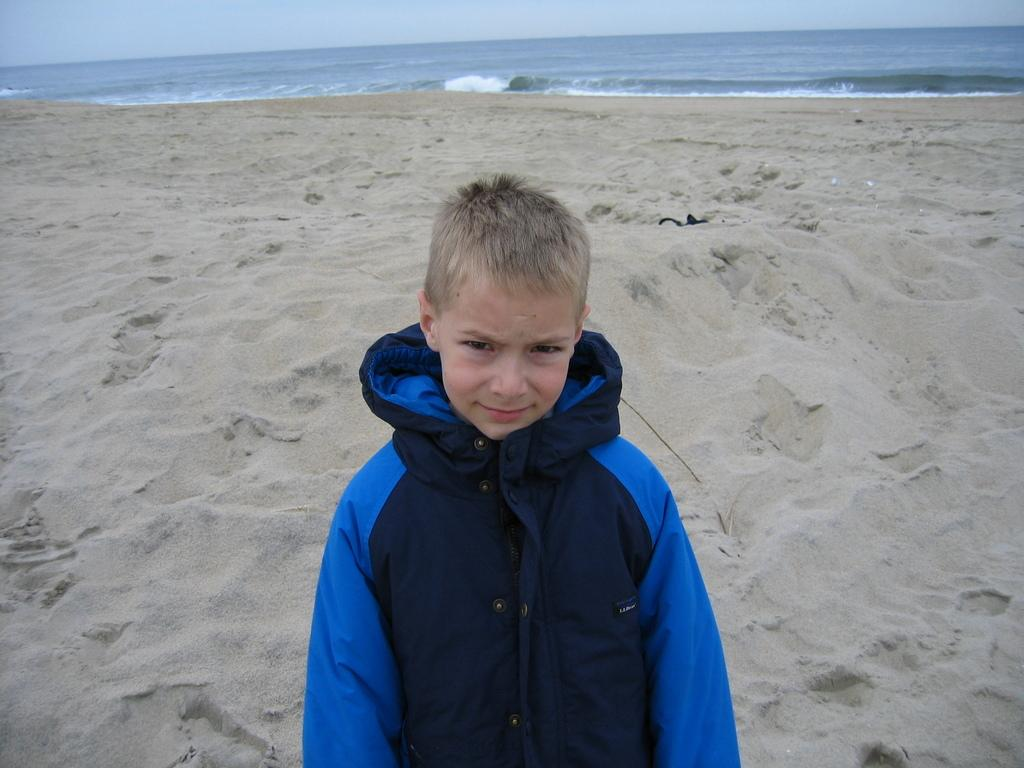Where was the image taken? The image was taken outside. What can be seen in the foreground of the image? There is a kid standing in the foreground of the image. What is visible in the background of the image? The sky and a water body are visible in the background of the image. What type of terrain is present in the background of the image? Mud is present in the background of the image. What type of eggnog is being served in the image? There is no eggnog present in the image. How does the cub interact with the water body in the image? There is no cub present in the image; it only features a kid and the water body. 